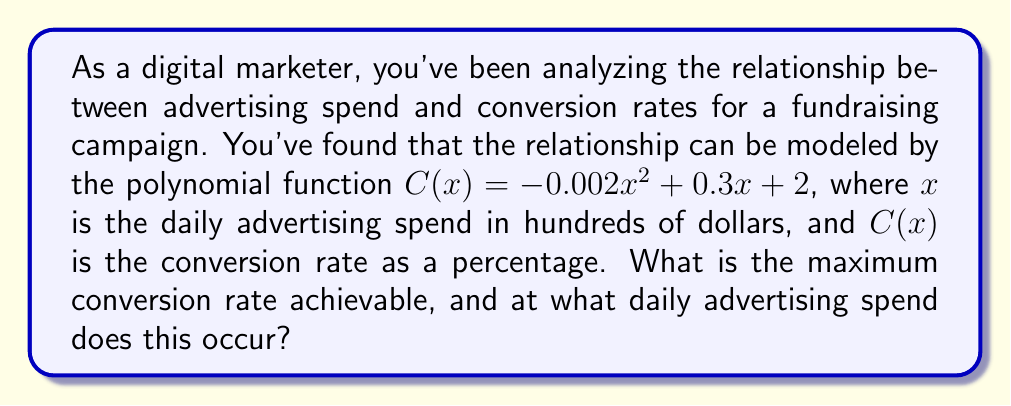Show me your answer to this math problem. To find the maximum conversion rate and the corresponding advertising spend, we need to follow these steps:

1) The function $C(x) = -0.002x^2 + 0.3x + 2$ is a quadratic function, which forms a parabola when graphed. The maximum point of this parabola will give us the maximum conversion rate.

2) To find the maximum point, we need to find the vertex of the parabola. For a quadratic function in the form $ax^2 + bx + c$, the x-coordinate of the vertex is given by $x = -\frac{b}{2a}$.

3) In our function, $a = -0.002$ and $b = 0.3$. Let's substitute these values:

   $x = -\frac{0.3}{2(-0.002)} = -\frac{0.3}{-0.004} = 75$

4) This means the maximum occurs when $x = 75$, which represents a daily advertising spend of $75 \times 100 = 7,500$ dollars.

5) To find the maximum conversion rate, we need to calculate $C(75)$:

   $C(75) = -0.002(75)^2 + 0.3(75) + 2$
   $= -0.002(5625) + 22.5 + 2$
   $= -11.25 + 22.5 + 2$
   $= 13.25$

Therefore, the maximum conversion rate is 13.25%.
Answer: Maximum conversion rate: 13.25%; Daily advertising spend: $7,500 